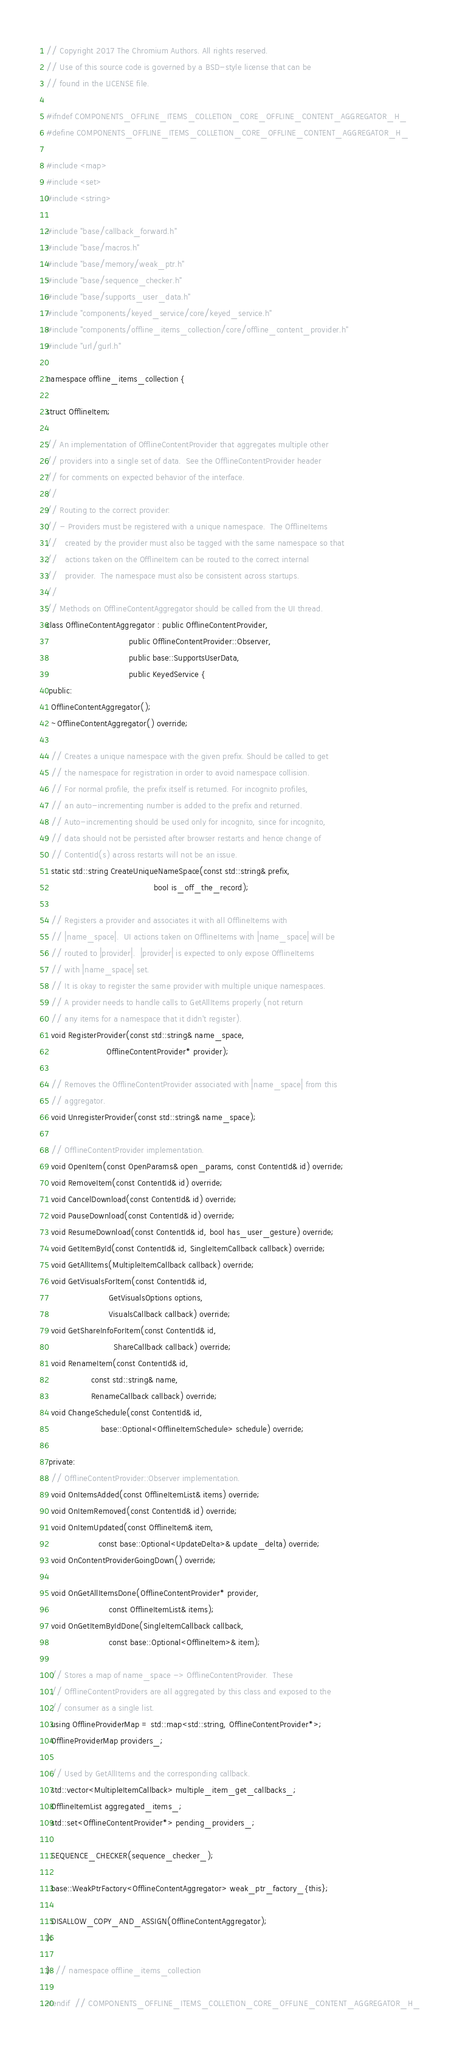Convert code to text. <code><loc_0><loc_0><loc_500><loc_500><_C_>// Copyright 2017 The Chromium Authors. All rights reserved.
// Use of this source code is governed by a BSD-style license that can be
// found in the LICENSE file.

#ifndef COMPONENTS_OFFLINE_ITEMS_COLLETION_CORE_OFFLINE_CONTENT_AGGREGATOR_H_
#define COMPONENTS_OFFLINE_ITEMS_COLLETION_CORE_OFFLINE_CONTENT_AGGREGATOR_H_

#include <map>
#include <set>
#include <string>

#include "base/callback_forward.h"
#include "base/macros.h"
#include "base/memory/weak_ptr.h"
#include "base/sequence_checker.h"
#include "base/supports_user_data.h"
#include "components/keyed_service/core/keyed_service.h"
#include "components/offline_items_collection/core/offline_content_provider.h"
#include "url/gurl.h"

namespace offline_items_collection {

struct OfflineItem;

// An implementation of OfflineContentProvider that aggregates multiple other
// providers into a single set of data.  See the OfflineContentProvider header
// for comments on expected behavior of the interface.
//
// Routing to the correct provider:
// - Providers must be registered with a unique namespace.  The OfflineItems
//   created by the provider must also be tagged with the same namespace so that
//   actions taken on the OfflineItem can be routed to the correct internal
//   provider.  The namespace must also be consistent across startups.
//
// Methods on OfflineContentAggregator should be called from the UI thread.
class OfflineContentAggregator : public OfflineContentProvider,
                                 public OfflineContentProvider::Observer,
                                 public base::SupportsUserData,
                                 public KeyedService {
 public:
  OfflineContentAggregator();
  ~OfflineContentAggregator() override;

  // Creates a unique namespace with the given prefix. Should be called to get
  // the namespace for registration in order to avoid namespace collision.
  // For normal profile, the prefix itself is returned. For incognito profiles,
  // an auto-incrementing number is added to the prefix and returned.
  // Auto-incrementing should be used only for incognito, since for incognito,
  // data should not be persisted after browser restarts and hence change of
  // ContentId(s) across restarts will not be an issue.
  static std::string CreateUniqueNameSpace(const std::string& prefix,
                                           bool is_off_the_record);

  // Registers a provider and associates it with all OfflineItems with
  // |name_space|.  UI actions taken on OfflineItems with |name_space| will be
  // routed to |provider|.  |provider| is expected to only expose OfflineItems
  // with |name_space| set.
  // It is okay to register the same provider with multiple unique namespaces.
  // A provider needs to handle calls to GetAllItems properly (not return
  // any items for a namespace that it didn't register).
  void RegisterProvider(const std::string& name_space,
                        OfflineContentProvider* provider);

  // Removes the OfflineContentProvider associated with |name_space| from this
  // aggregator.
  void UnregisterProvider(const std::string& name_space);

  // OfflineContentProvider implementation.
  void OpenItem(const OpenParams& open_params, const ContentId& id) override;
  void RemoveItem(const ContentId& id) override;
  void CancelDownload(const ContentId& id) override;
  void PauseDownload(const ContentId& id) override;
  void ResumeDownload(const ContentId& id, bool has_user_gesture) override;
  void GetItemById(const ContentId& id, SingleItemCallback callback) override;
  void GetAllItems(MultipleItemCallback callback) override;
  void GetVisualsForItem(const ContentId& id,
                         GetVisualsOptions options,
                         VisualsCallback callback) override;
  void GetShareInfoForItem(const ContentId& id,
                           ShareCallback callback) override;
  void RenameItem(const ContentId& id,
                  const std::string& name,
                  RenameCallback callback) override;
  void ChangeSchedule(const ContentId& id,
                      base::Optional<OfflineItemSchedule> schedule) override;

 private:
  // OfflineContentProvider::Observer implementation.
  void OnItemsAdded(const OfflineItemList& items) override;
  void OnItemRemoved(const ContentId& id) override;
  void OnItemUpdated(const OfflineItem& item,
                     const base::Optional<UpdateDelta>& update_delta) override;
  void OnContentProviderGoingDown() override;

  void OnGetAllItemsDone(OfflineContentProvider* provider,
                         const OfflineItemList& items);
  void OnGetItemByIdDone(SingleItemCallback callback,
                         const base::Optional<OfflineItem>& item);

  // Stores a map of name_space -> OfflineContentProvider.  These
  // OfflineContentProviders are all aggregated by this class and exposed to the
  // consumer as a single list.
  using OfflineProviderMap = std::map<std::string, OfflineContentProvider*>;
  OfflineProviderMap providers_;

  // Used by GetAllItems and the corresponding callback.
  std::vector<MultipleItemCallback> multiple_item_get_callbacks_;
  OfflineItemList aggregated_items_;
  std::set<OfflineContentProvider*> pending_providers_;

  SEQUENCE_CHECKER(sequence_checker_);

  base::WeakPtrFactory<OfflineContentAggregator> weak_ptr_factory_{this};

  DISALLOW_COPY_AND_ASSIGN(OfflineContentAggregator);
};

}  // namespace offline_items_collection

#endif  // COMPONENTS_OFFLINE_ITEMS_COLLETION_CORE_OFFLINE_CONTENT_AGGREGATOR_H_
</code> 